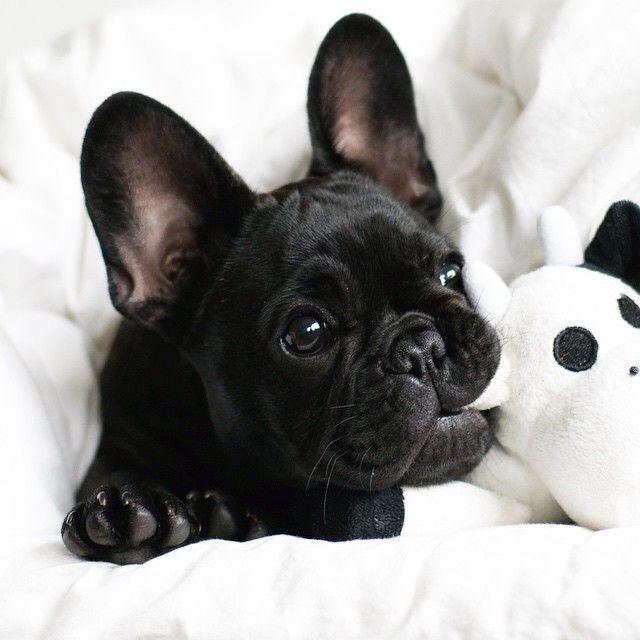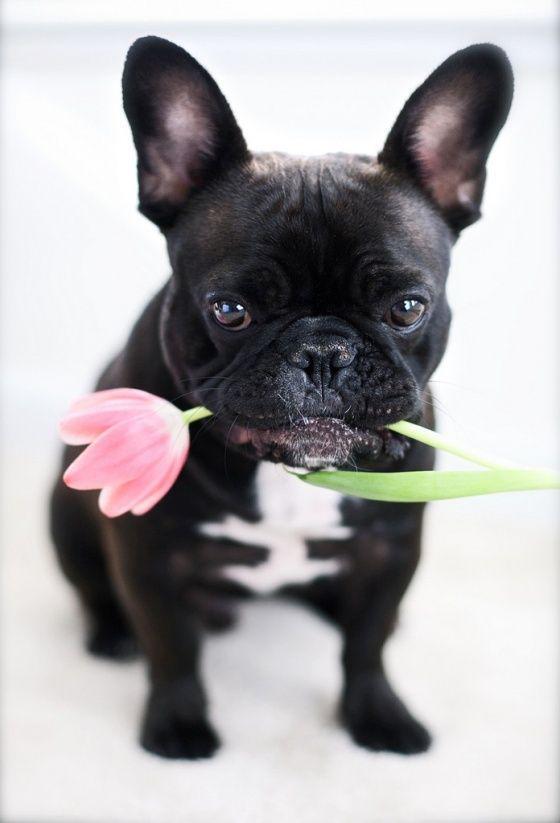The first image is the image on the left, the second image is the image on the right. Considering the images on both sides, is "One dog has its mouth open and another dog has its mouth closed, and one of them is wearing a tie." valid? Answer yes or no. No. The first image is the image on the left, the second image is the image on the right. Given the left and right images, does the statement "An image shows one dog, which is wearing something made of printed fabric around its neck." hold true? Answer yes or no. No. 